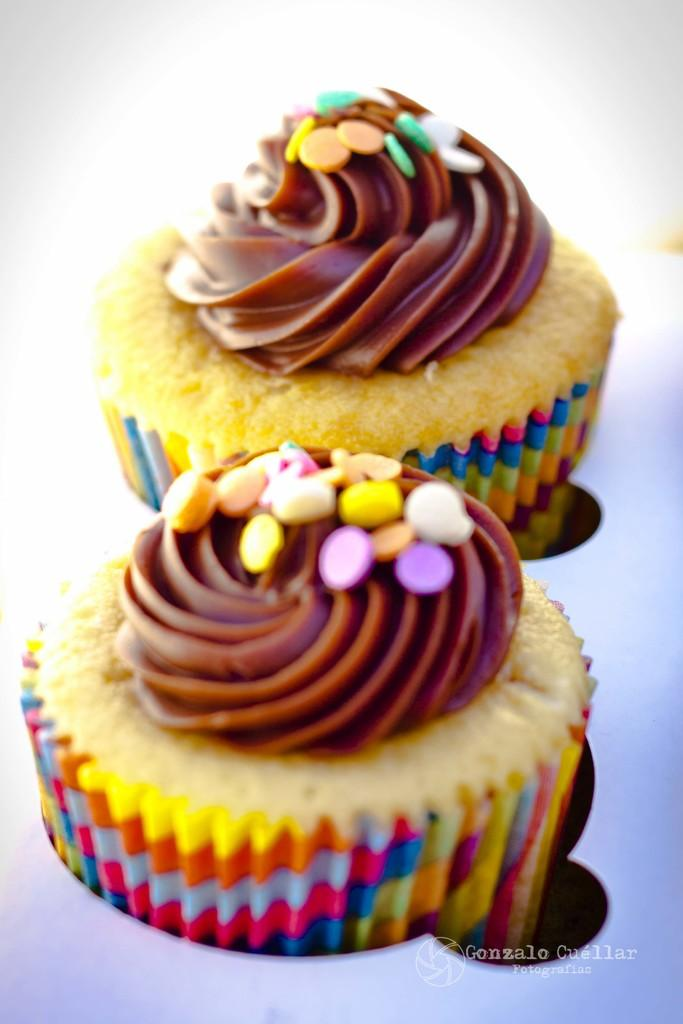What type of dessert can be seen in the image? There are cupcakes in the image. How many ladybugs can be seen on top of the cupcakes in the image? There are no ladybugs present on the cupcakes in the image. What type of animal is grazing in the background of the image? There is no background or animal visible in the image; it only features cupcakes. 